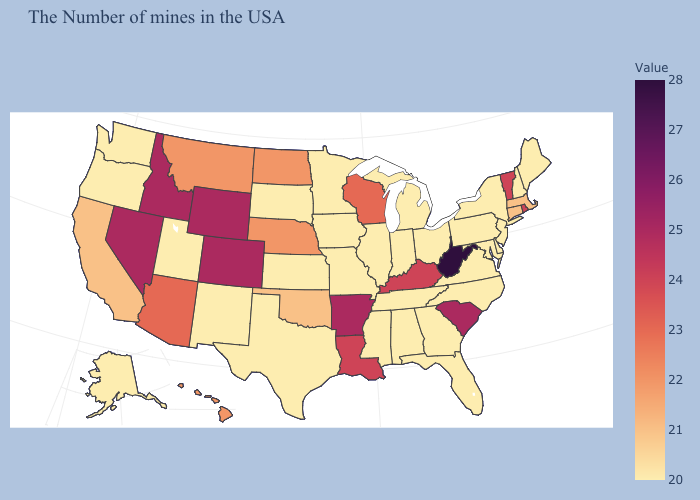Does Maine have the lowest value in the USA?
Be succinct. Yes. Among the states that border Massachusetts , which have the lowest value?
Keep it brief. New Hampshire, New York. Which states hav the highest value in the MidWest?
Short answer required. Wisconsin. Which states have the lowest value in the MidWest?
Keep it brief. Ohio, Michigan, Indiana, Illinois, Missouri, Minnesota, Iowa, Kansas, South Dakota. Which states have the lowest value in the USA?
Keep it brief. Maine, New Hampshire, New York, New Jersey, Delaware, Maryland, Pennsylvania, Virginia, North Carolina, Ohio, Florida, Georgia, Michigan, Indiana, Alabama, Tennessee, Illinois, Mississippi, Missouri, Minnesota, Iowa, Kansas, Texas, South Dakota, New Mexico, Utah, Washington, Oregon, Alaska. Does New Jersey have a higher value than Vermont?
Concise answer only. No. 